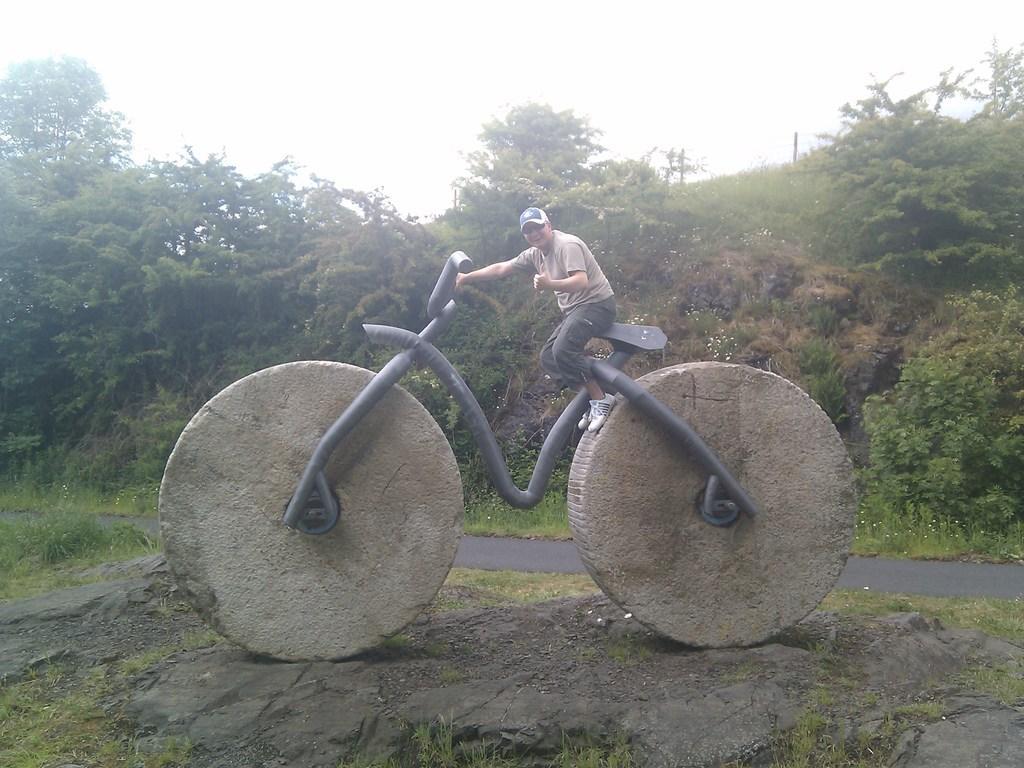What is the person sitting on in the image? The person is sitting on a statue. What is the statue a representation of? The statue is of a bicycle. What can be seen in the background of the image? There are trees and plants in the distance. What type of lunch is being served at the airport in the image? There is no airport or lunch present in the image; it features a person sitting on a bicycle statue with trees and plants in the background. 